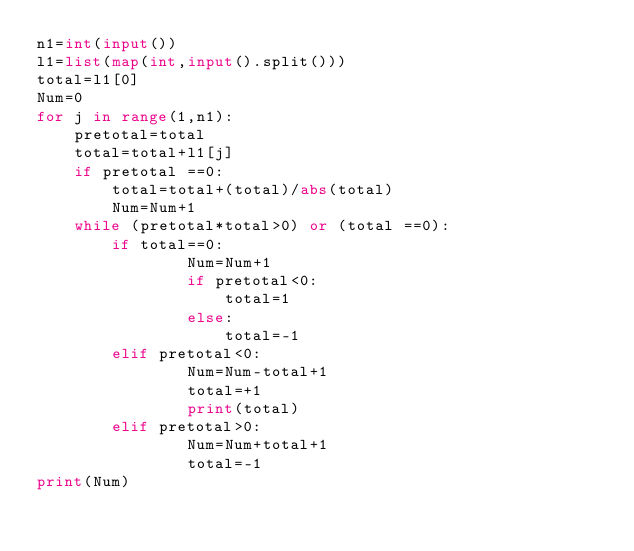<code> <loc_0><loc_0><loc_500><loc_500><_Python_>n1=int(input())
l1=list(map(int,input().split()))
total=l1[0]
Num=0
for j in range(1,n1):
    pretotal=total
    total=total+l1[j]
    if pretotal ==0:
        total=total+(total)/abs(total)
        Num=Num+1
    while (pretotal*total>0) or (total ==0):
        if total==0:
                Num=Num+1
                if pretotal<0:
                    total=1
                else:
                    total=-1
        elif pretotal<0:
                Num=Num-total+1
                total=+1
                print(total)
        elif pretotal>0:
                Num=Num+total+1
                total=-1
print(Num)</code> 